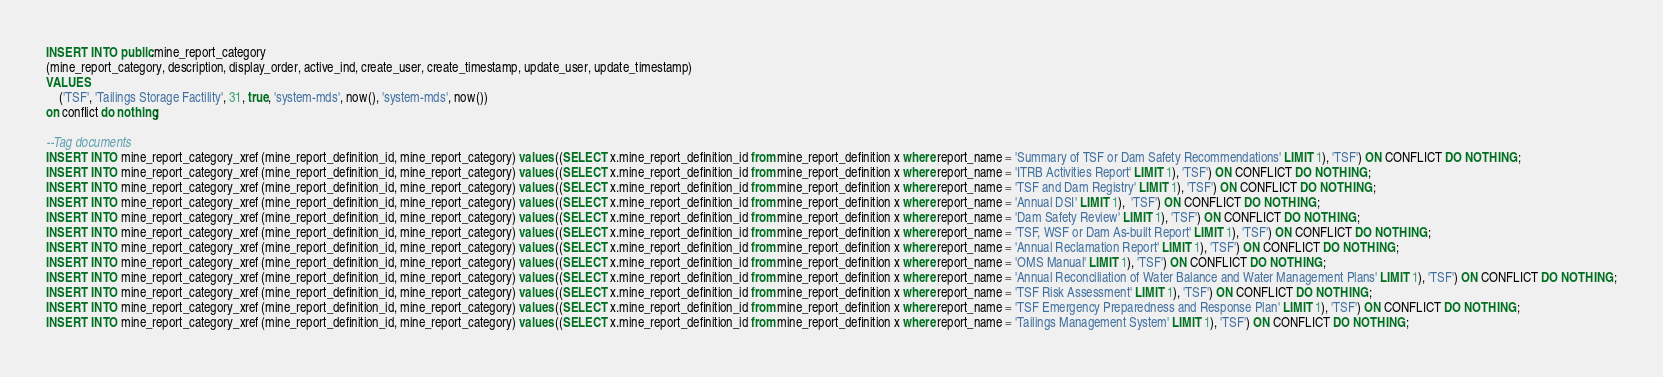<code> <loc_0><loc_0><loc_500><loc_500><_SQL_>

INSERT INTO public.mine_report_category
(mine_report_category, description, display_order, active_ind, create_user, create_timestamp, update_user, update_timestamp)
VALUES 
	('TSF', 'Tailings Storage Factility', 31, true, 'system-mds', now(), 'system-mds', now())
on conflict do nothing;

--Tag documents
INSERT INTO mine_report_category_xref (mine_report_definition_id, mine_report_category) values ((SELECT x.mine_report_definition_id from mine_report_definition x where report_name = 'Summary of TSF or Dam Safety Recommendations' LIMIT 1), 'TSF') ON CONFLICT DO NOTHING;
INSERT INTO mine_report_category_xref (mine_report_definition_id, mine_report_category) values ((SELECT x.mine_report_definition_id from mine_report_definition x where report_name = 'ITRB Activities Report' LIMIT 1), 'TSF') ON CONFLICT DO NOTHING;
INSERT INTO mine_report_category_xref (mine_report_definition_id, mine_report_category) values ((SELECT x.mine_report_definition_id from mine_report_definition x where report_name = 'TSF and Dam Registry' LIMIT 1), 'TSF') ON CONFLICT DO NOTHING;
INSERT INTO mine_report_category_xref (mine_report_definition_id, mine_report_category) values ((SELECT x.mine_report_definition_id from mine_report_definition x where report_name = 'Annual DSI' LIMIT 1),  'TSF') ON CONFLICT DO NOTHING;
INSERT INTO mine_report_category_xref (mine_report_definition_id, mine_report_category) values ((SELECT x.mine_report_definition_id from mine_report_definition x where report_name = 'Dam Safety Review' LIMIT 1), 'TSF') ON CONFLICT DO NOTHING;
INSERT INTO mine_report_category_xref (mine_report_definition_id, mine_report_category) values ((SELECT x.mine_report_definition_id from mine_report_definition x where report_name = 'TSF, WSF or Dam As-built Report' LIMIT 1), 'TSF') ON CONFLICT DO NOTHING;
INSERT INTO mine_report_category_xref (mine_report_definition_id, mine_report_category) values ((SELECT x.mine_report_definition_id from mine_report_definition x where report_name = 'Annual Reclamation Report' LIMIT 1), 'TSF') ON CONFLICT DO NOTHING;
INSERT INTO mine_report_category_xref (mine_report_definition_id, mine_report_category) values ((SELECT x.mine_report_definition_id from mine_report_definition x where report_name = 'OMS Manual' LIMIT 1), 'TSF') ON CONFLICT DO NOTHING;
INSERT INTO mine_report_category_xref (mine_report_definition_id, mine_report_category) values ((SELECT x.mine_report_definition_id from mine_report_definition x where report_name = 'Annual Reconciliation of Water Balance and Water Management Plans' LIMIT 1), 'TSF') ON CONFLICT DO NOTHING;
INSERT INTO mine_report_category_xref (mine_report_definition_id, mine_report_category) values ((SELECT x.mine_report_definition_id from mine_report_definition x where report_name = 'TSF Risk Assessment' LIMIT 1), 'TSF') ON CONFLICT DO NOTHING;
INSERT INTO mine_report_category_xref (mine_report_definition_id, mine_report_category) values ((SELECT x.mine_report_definition_id from mine_report_definition x where report_name = 'TSF Emergency Preparedness and Response Plan' LIMIT 1), 'TSF') ON CONFLICT DO NOTHING;
INSERT INTO mine_report_category_xref (mine_report_definition_id, mine_report_category) values ((SELECT x.mine_report_definition_id from mine_report_definition x where report_name = 'Tailings Management System' LIMIT 1), 'TSF') ON CONFLICT DO NOTHING;</code> 